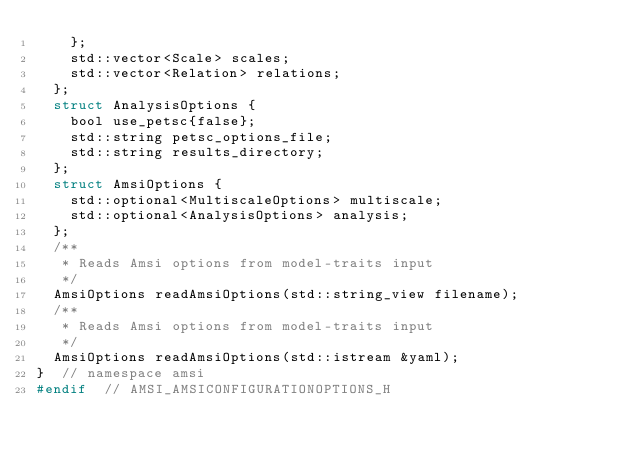Convert code to text. <code><loc_0><loc_0><loc_500><loc_500><_C_>    };
    std::vector<Scale> scales;
    std::vector<Relation> relations;
  };
  struct AnalysisOptions {
    bool use_petsc{false};
    std::string petsc_options_file;
    std::string results_directory;
  };
  struct AmsiOptions {
    std::optional<MultiscaleOptions> multiscale;
    std::optional<AnalysisOptions> analysis;
  };
  /**
   * Reads Amsi options from model-traits input
   */
  AmsiOptions readAmsiOptions(std::string_view filename);
  /**
   * Reads Amsi options from model-traits input
   */
  AmsiOptions readAmsiOptions(std::istream &yaml);
}  // namespace amsi
#endif  // AMSI_AMSICONFIGURATIONOPTIONS_H
</code> 